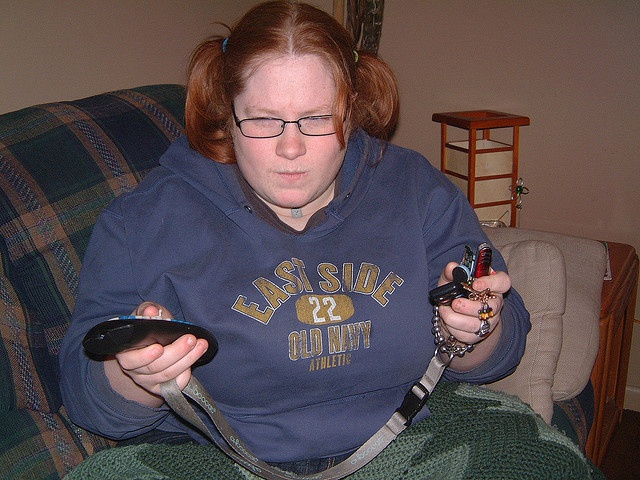Describe the objects in this image and their specific colors. I can see people in gray, black, navy, and darkblue tones, couch in gray and black tones, and remote in gray, black, maroon, and navy tones in this image. 